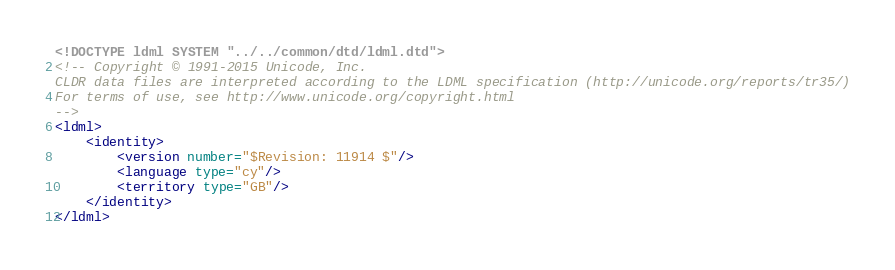<code> <loc_0><loc_0><loc_500><loc_500><_XML_><!DOCTYPE ldml SYSTEM "../../common/dtd/ldml.dtd">
<!-- Copyright © 1991-2015 Unicode, Inc.
CLDR data files are interpreted according to the LDML specification (http://unicode.org/reports/tr35/)
For terms of use, see http://www.unicode.org/copyright.html
-->
<ldml>
	<identity>
		<version number="$Revision: 11914 $"/>
		<language type="cy"/>
		<territory type="GB"/>
	</identity>
</ldml>

</code> 